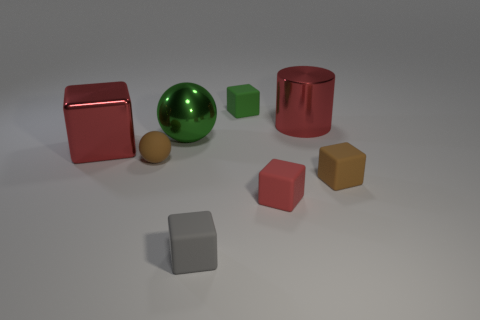There is a object that is the same color as the small rubber sphere; what is its material?
Provide a succinct answer. Rubber. What is the size of the rubber object that is the same color as the large shiny sphere?
Keep it short and to the point. Small. Is there a green cube of the same size as the gray thing?
Provide a short and direct response. Yes. There is a small block that is behind the brown rubber block; is it the same color as the big thing on the right side of the green rubber object?
Provide a short and direct response. No. Are there any other big metallic cylinders that have the same color as the cylinder?
Offer a terse response. No. How many other things are there of the same shape as the small red thing?
Your answer should be compact. 4. What shape is the tiny object that is right of the small red thing?
Your response must be concise. Cube. Does the gray matte thing have the same shape as the red metallic thing behind the big cube?
Give a very brief answer. No. There is a object that is behind the large red shiny block and to the right of the green block; how big is it?
Offer a terse response. Large. What is the color of the tiny cube that is both left of the red rubber cube and behind the gray thing?
Ensure brevity in your answer.  Green. 